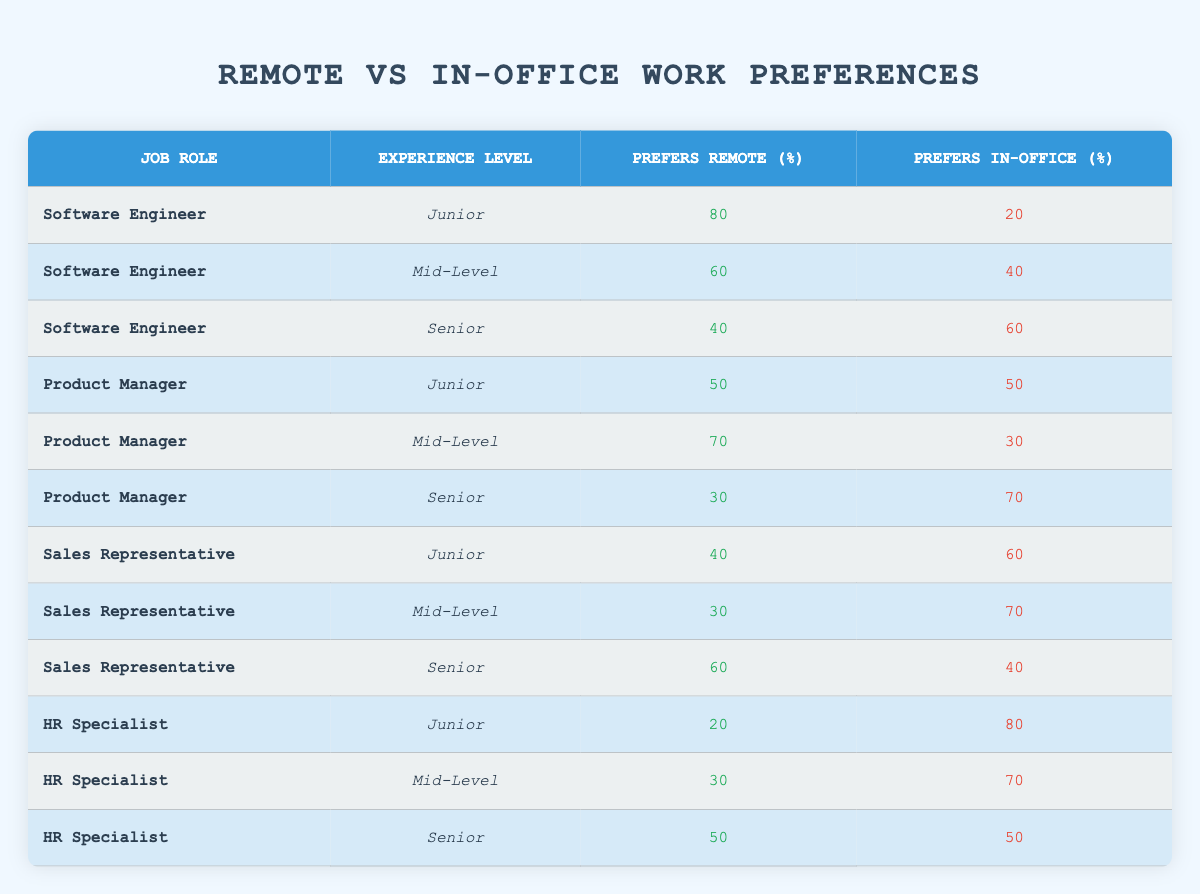What percentage of Senior Software Engineers prefer remote work? According to the table, Senior Software Engineers prefer remote work at a rate of 40%. This value can be found under the "Prefers Remote (%)" column for the corresponding job role and experience level.
Answer: 40 How many Junior Product Managers prefer remote work? The table shows that Junior Product Managers prefer remote work at a percentage of 50%. This is a straightforward retrieval from the "Prefers Remote (%)" column for the respective job role and experience.
Answer: 50 Which job role has the highest percentage of employees preferring remote work? Looking across the table, the job role of Software Engineer at the Junior level has the highest preference for remote work at 80%. This was determined by comparing the percentages in the "Prefers Remote (%)" column across all job roles.
Answer: Software Engineer (Junior) What is the average percentage of employees who prefer remote work across all Senior roles? The table has three Senior roles: Software Engineer (40%), Product Manager (30%), and Sales Representative (60%). To calculate the average, we sum these percentages: 40 + 30 + 60 = 130. Then we divide by the number of roles: 130 / 3 = approximately 43.33%. This gives us the average preference for remote work among Seniors.
Answer: Approximately 43.33 Do Mid-Level HR Specialists have a higher preference for remote work than Senior HR Specialists? Mid-Level HR Specialists prefer remote work at 30%, while Senior HR Specialists prefer 50%. Since 30% is less than 50%, it is true that Mid-Level HR Specialists have a lower preference for remote work.
Answer: No What is the total percentage of Senior level employees preferring in-office work? In the table, we find all Senior role in-office percentages: Software Engineer (60%), Product Manager (70%), Sales Representative (40%), and HR Specialist (50%). Adding these gives: 60 + 70 + 40 + 50 = 220%. To find the total percentage of Senior employees who prefer in-office work, we simply sum these values.
Answer: 220 How do the preferences for remote work differ between Junior and Senior Sales Representatives? Junior Sales Representatives prefer remote work at 40%, while Senior Sales Representatives prefer remote work at 60%. This shows that Senior Sales Representatives have a stronger preference for remote work compared to Junior Sales Representatives.
Answer: Seniors prefer remote more What percentage of Mid-Level Software Engineers prefer in-office work? The table indicates that Mid-Level Software Engineers prefer in-office work at a rate of 40%. This figure is directly taken from the "Prefers In-Office (%)" column for that particular job role and level of experience.
Answer: 40 Is it true that all Product Managers have more employees preferring in-office work compared to remote work? For Junior Product Managers, the preference is equal (50%). For Mid-Level, 30% prefer in-office, while for Senior, 70% prefer in-office. Since one Junior role has equal preference, the statement is not true.
Answer: No 